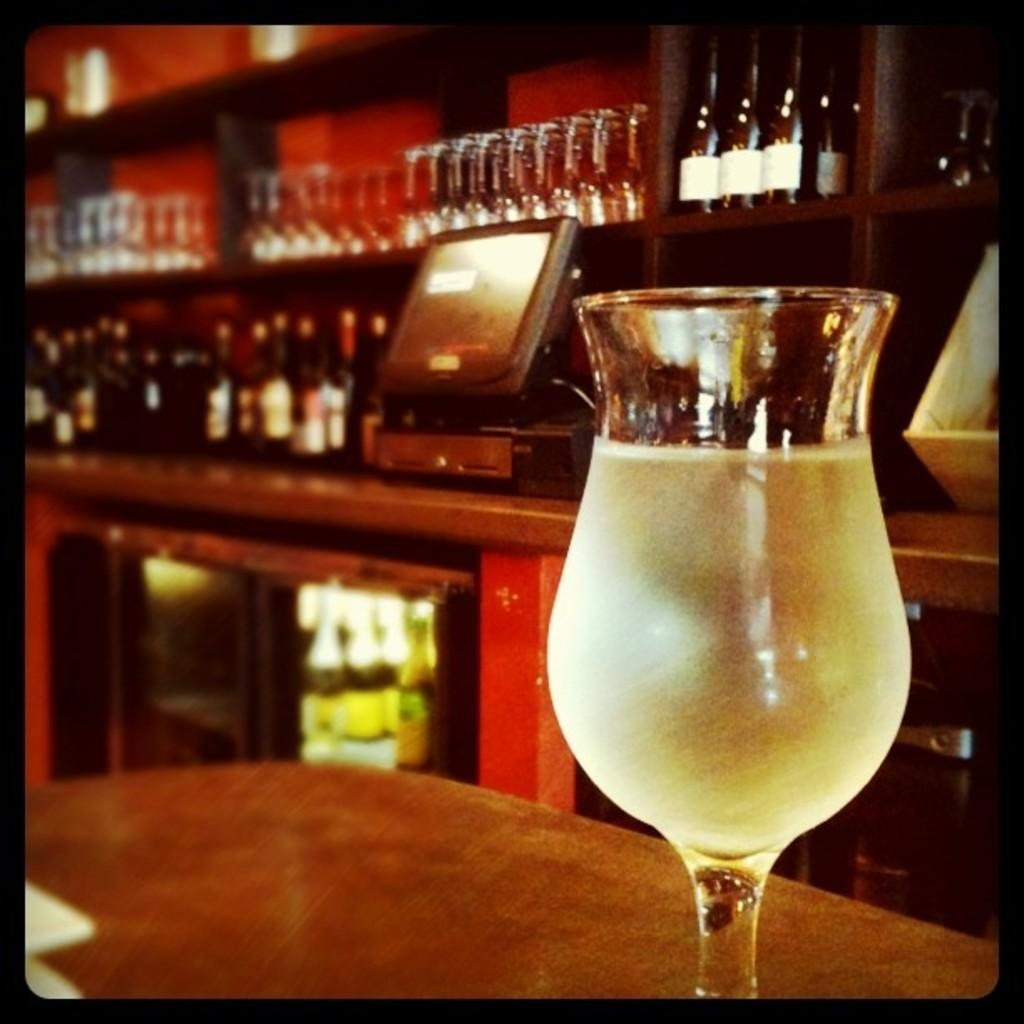What type of glass can be seen in the image? There is a wine glass in the image. What is the main piece of furniture in the image? There is a table in the image. What other alcohol-related items are present in the image? There are alcohol bottles in the image. What type of electronic device is visible in the image? There is an electronic device in the image. How does the jellyfish contribute to the acoustics of the room in the image? There are no jellyfish present in the image, so it cannot contribute to the acoustics of the room. 